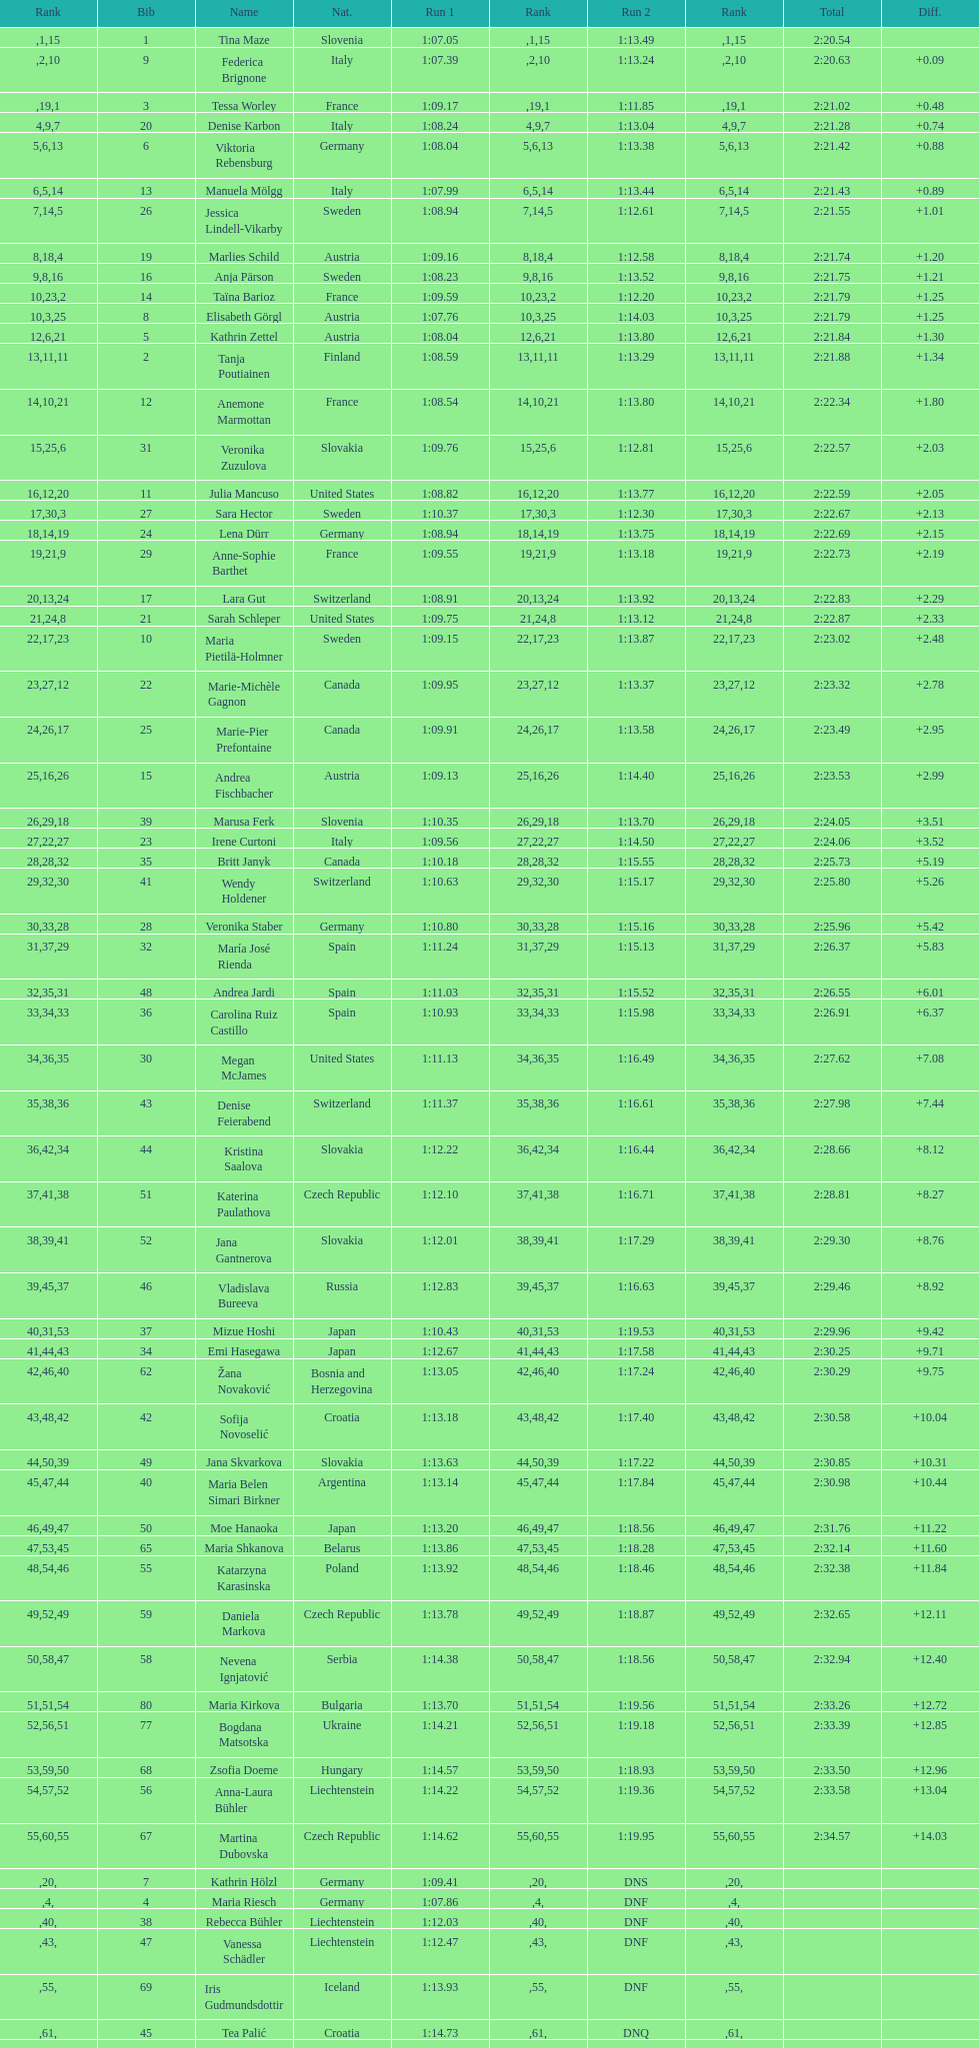How many italians finished in the top ten? 3. 